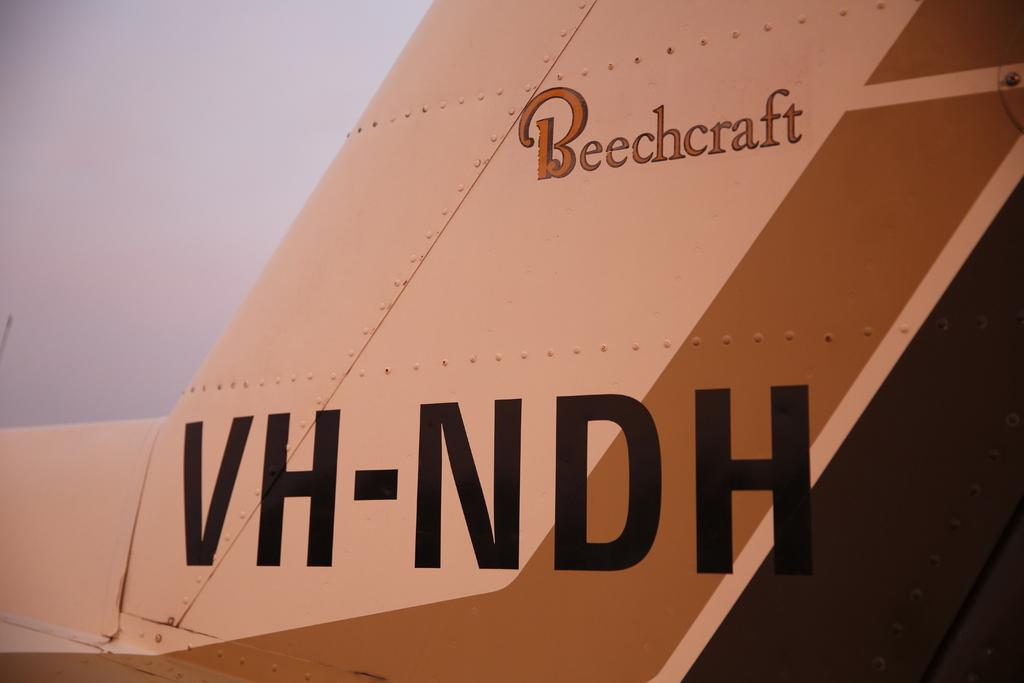<image>
Offer a succinct explanation of the picture presented. A Beechcraft airplane has the letters VH-NDh written on the back tail 